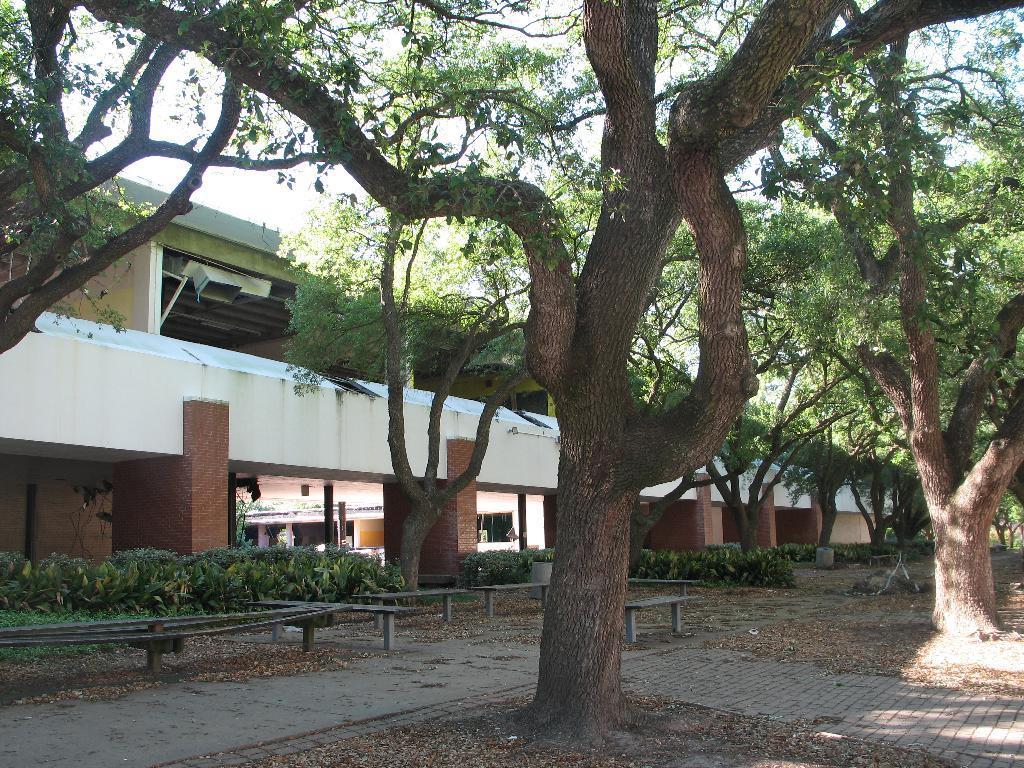Describe this image in one or two sentences. In the center of the image we can see the building, pillars, poles, roof, wall, trees. At the bottom of the image we can see some plants, benches, dry leaves and ground. At the top of the image we can see the sky. 